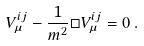Convert formula to latex. <formula><loc_0><loc_0><loc_500><loc_500>V _ { \mu } ^ { i j } - \frac { 1 } { m ^ { 2 } } \Box V _ { \mu } ^ { i j } = 0 \, .</formula> 